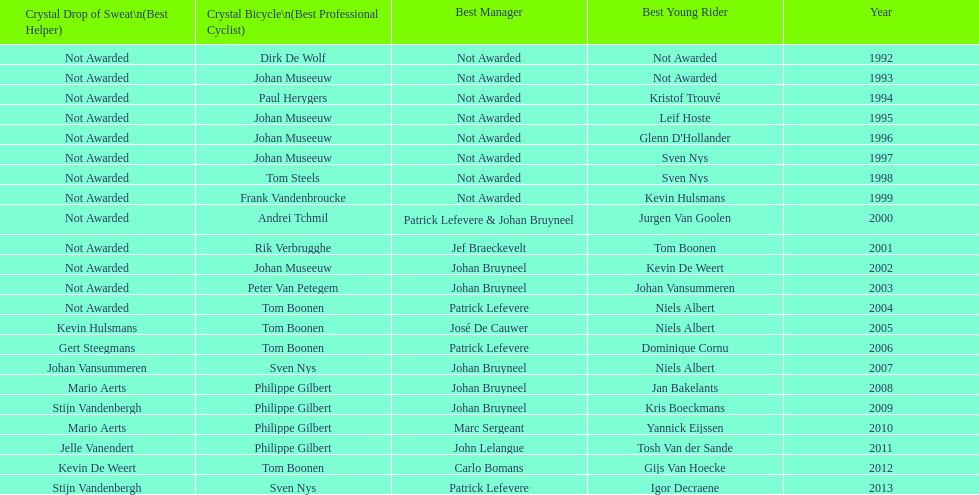Who won the crystal bicycle earlier, boonen or nys? Tom Boonen. 